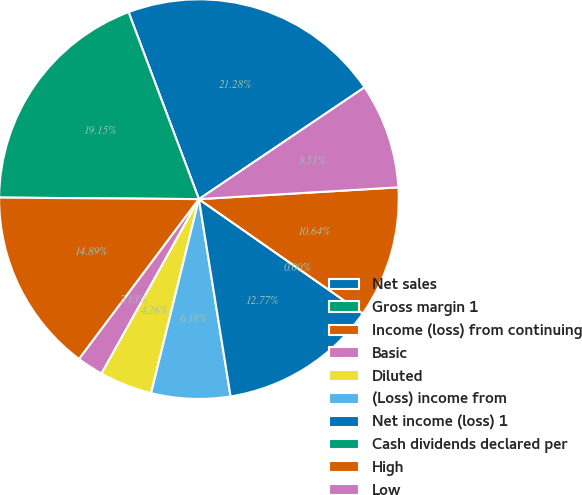<chart> <loc_0><loc_0><loc_500><loc_500><pie_chart><fcel>Net sales<fcel>Gross margin 1<fcel>Income (loss) from continuing<fcel>Basic<fcel>Diluted<fcel>(Loss) income from<fcel>Net income (loss) 1<fcel>Cash dividends declared per<fcel>High<fcel>Low<nl><fcel>21.28%<fcel>19.15%<fcel>14.89%<fcel>2.13%<fcel>4.26%<fcel>6.38%<fcel>12.77%<fcel>0.0%<fcel>10.64%<fcel>8.51%<nl></chart> 